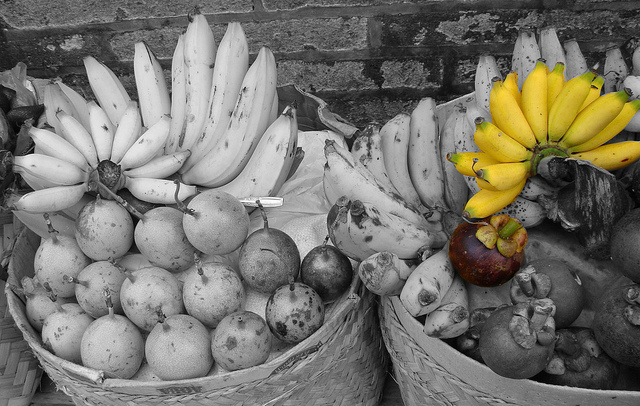What would the baskets look like in an alternate reality where fruit colors are reversed? In an alternate reality where fruit colors are reversed, the baskets would present a surreal and mesmerizing sight. The left basket, instead of housing monochromatic bananas, would display vibrant, multicolored bananas with unexpected hues. Imagine bananas in shades of deep purples, electric blues, and vivid pinks, creating a striking contrast against the grayscale basket. The round fruits that were once monochrome would now sparkle in a dazzling array of colors, resembling precious gems. In the right basket, the vividly yellow bananas would turn into a stark grey, almost blending into the woven basket if not for their distinct shapes. The purple fruit would transform into a bright, fiery red, standing out prominently among the now-muted bananas. This reversal of colors would give the familiar scene a fantastical, dreamlike quality, making the fruits appear otherworldly and almost magical. 